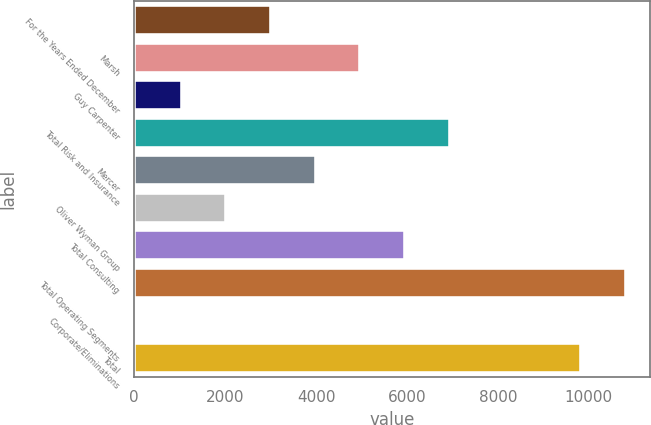Convert chart to OTSL. <chart><loc_0><loc_0><loc_500><loc_500><bar_chart><fcel>For the Years Ended December<fcel>Marsh<fcel>Guy Carpenter<fcel>Total Risk and Insurance<fcel>Mercer<fcel>Oliver Wyman Group<fcel>Total Consulting<fcel>Total Operating Segments<fcel>Corporate/Eliminations<fcel>Total<nl><fcel>3011.3<fcel>4977.5<fcel>1045.1<fcel>6943.7<fcel>3994.4<fcel>2028.2<fcel>5960.6<fcel>10814.1<fcel>62<fcel>9831<nl></chart> 